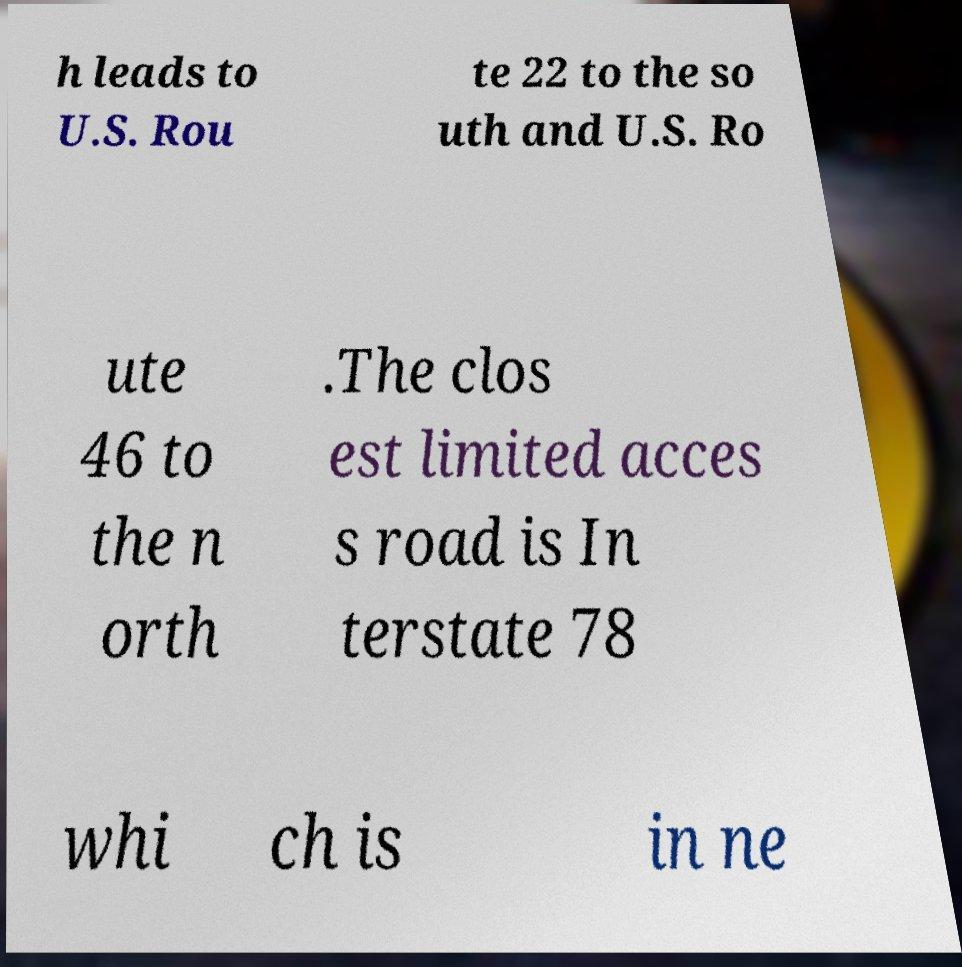There's text embedded in this image that I need extracted. Can you transcribe it verbatim? h leads to U.S. Rou te 22 to the so uth and U.S. Ro ute 46 to the n orth .The clos est limited acces s road is In terstate 78 whi ch is in ne 